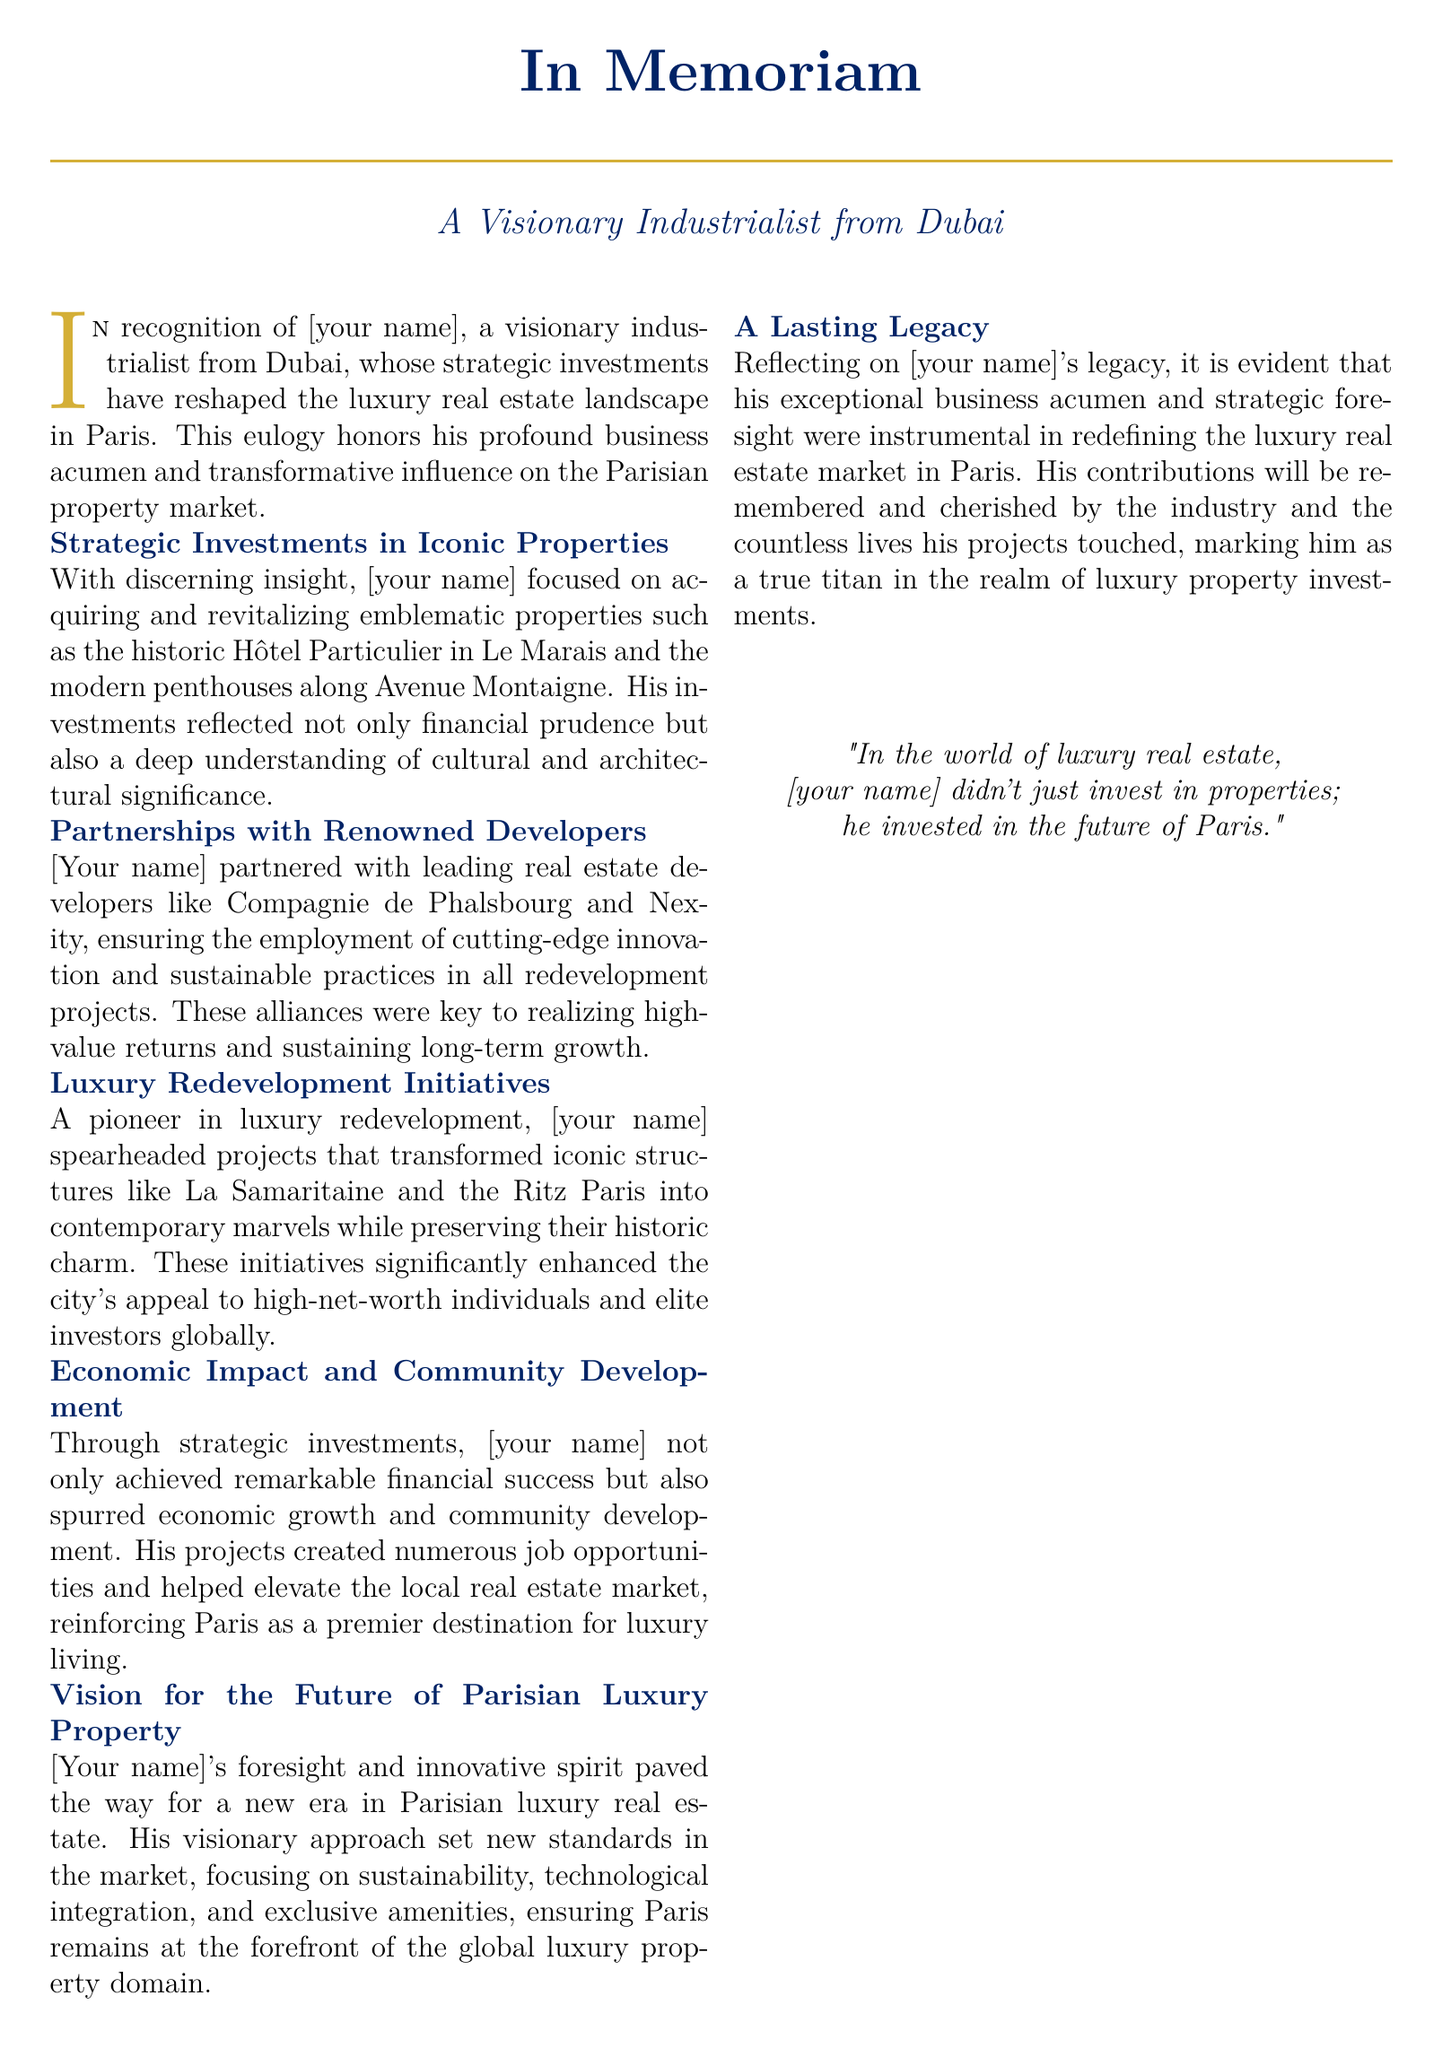what is the name of the visionary industrialist from Dubai? The document introduces the individual as a "visionary industrialist from Dubai" but does not provide a specific name.
Answer: [your name] which iconic properties were focused on in the strategic investments? The eulogy mentions "Hôtel Particulier in Le Marais" and "the modern penthouses along Avenue Montaigne" as iconic properties.
Answer: Hôtel Particulier, modern penthouses who were the partners mentioned in the redevelopment projects? The document lists "Compagnie de Phalsbourg" and "Nexity" as the partners in redevelopment projects.
Answer: Compagnie de Phalsbourg, Nexity what was a significant redevelopment initiative highlighted in the document? The eulogy points out the transformation of "La Samaritaine" and the "Ritz Paris" into contemporary marvels.
Answer: La Samaritaine, Ritz Paris what is a major impact of the strategic investments made by [your name]? The document states that the investments "spurred economic growth and community development."
Answer: Economic growth, community development what future vision did [your name] have for Parisian luxury property? The eulogy describes [your name]'s vision as one that focuses on "sustainability, technological integration, and exclusive amenities."
Answer: Sustainability, technological integration what phrase reflects [your name]'s investment philosophy? The closing statement of the document quotes that he "didn't just invest in properties; he invested in the future of Paris."
Answer: Invested in the future of Paris what color theme is used for titles and highlights in the document? The document frequently uses the color "deepblue" for titles and "goldaccent" for highlights.
Answer: Deep blue, gold accent 